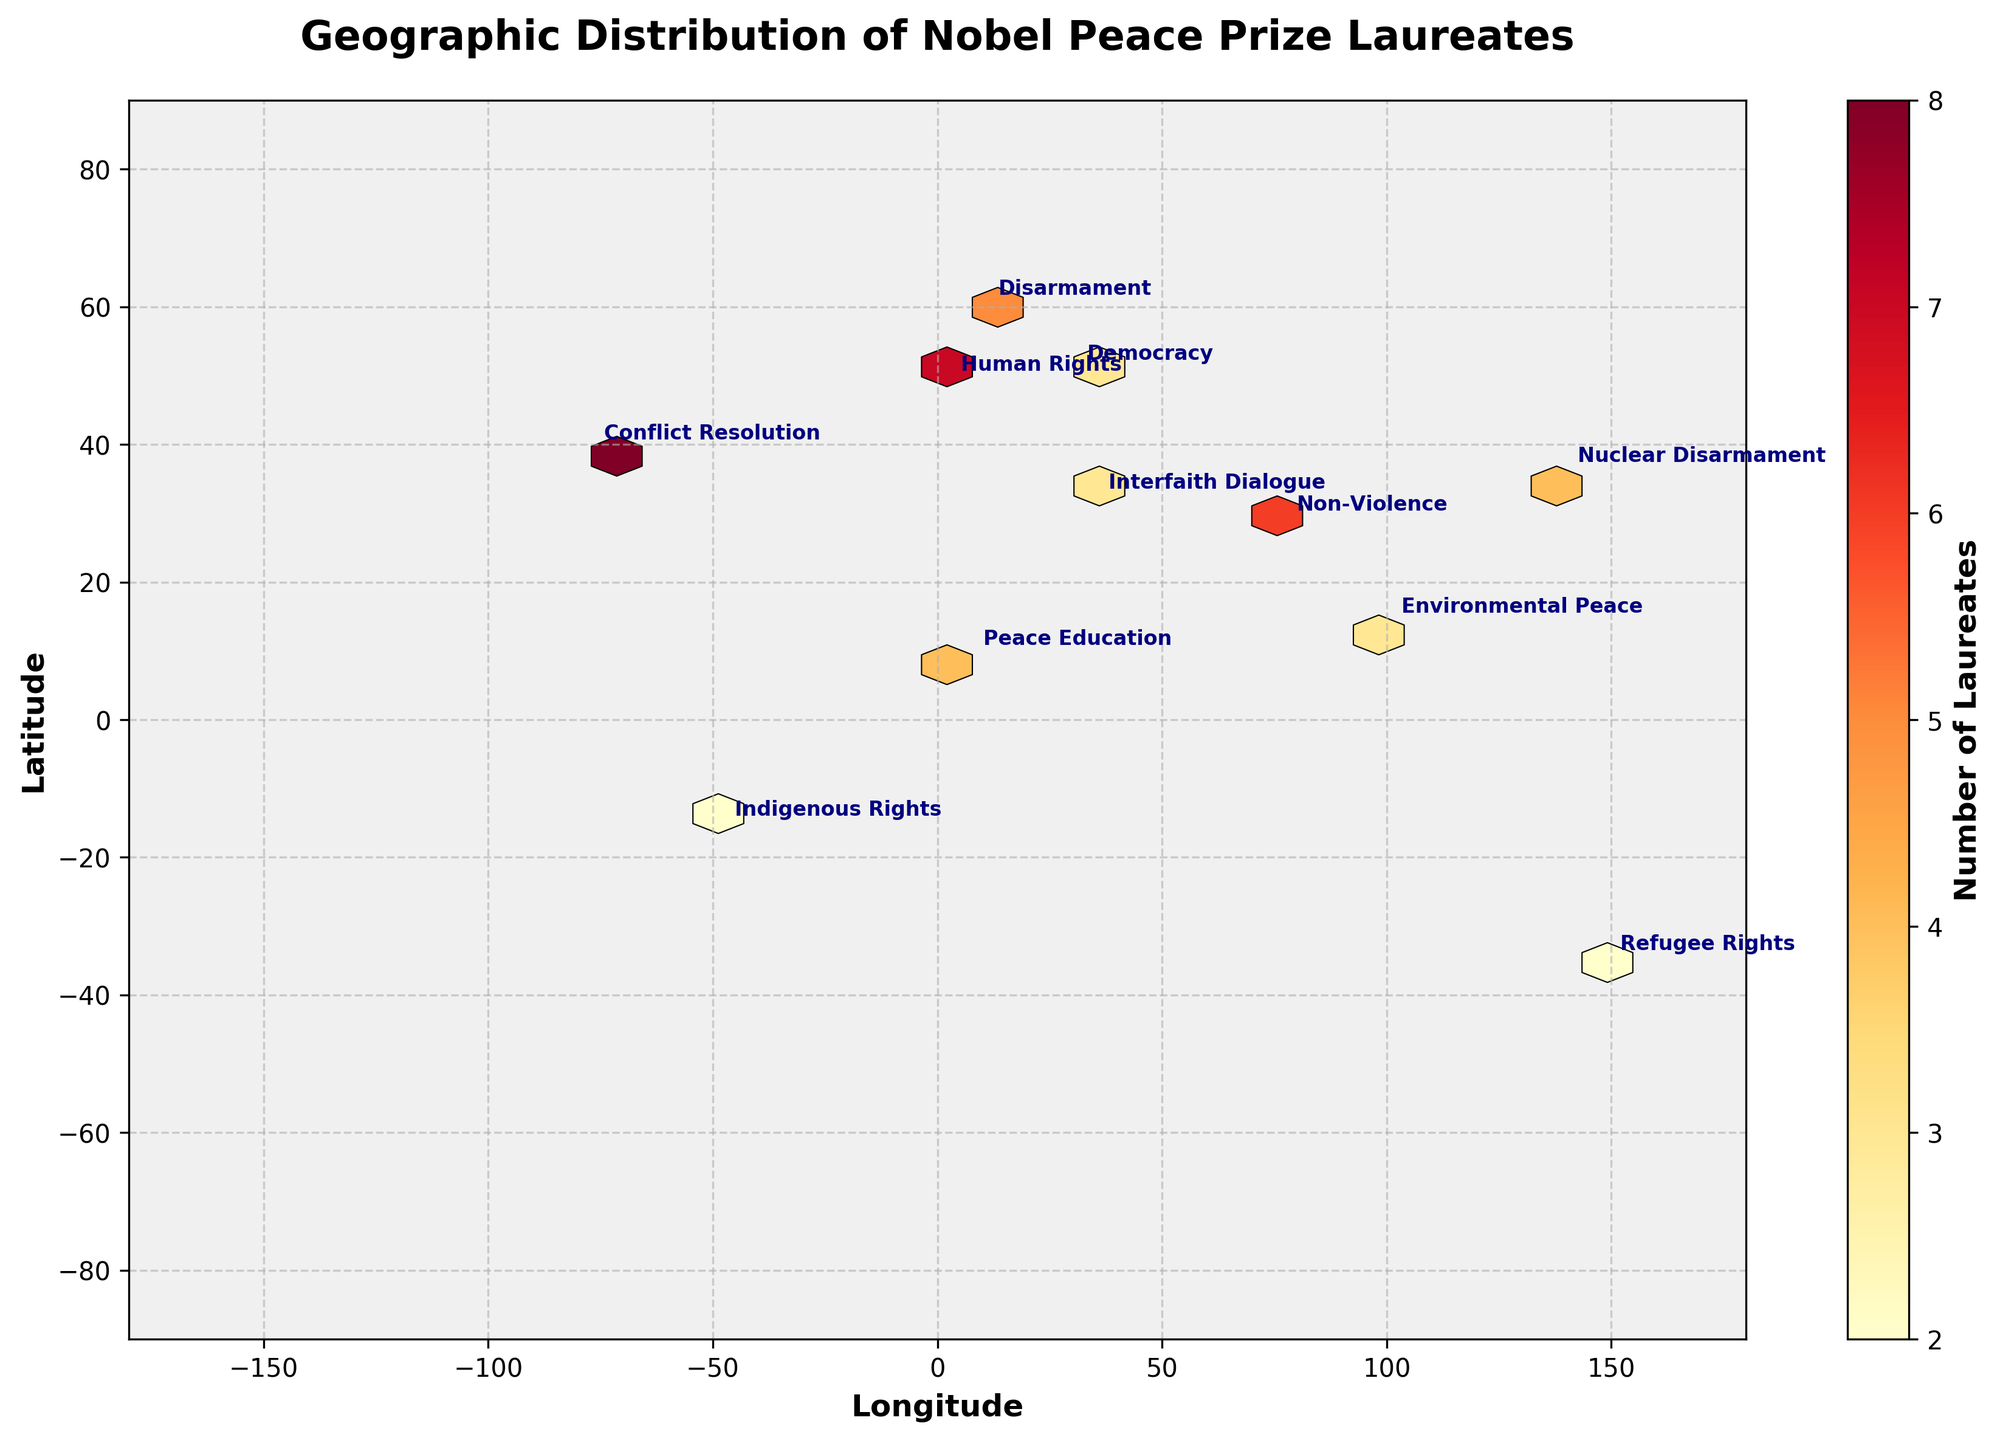What is the title of the plot? The title of the plot is prominently shown at the top in bold letters. It reads: "Geographic Distribution of Nobel Peace Prize Laureates".
Answer: Geographic Distribution of Nobel Peace Prize Laureates What does the color bar represent? The color bar is usually labeled to indicate what it represents. In this figure, it shows "Number of Laureates", which means the color intensity in each hexbin cell shows the count of Nobel Peace Prize laureates.
Answer: Number of Laureates What are the latitude and longitude ranges used in the plot? The plot's axes are labeled, showing geographic coordinates. The latitude range is from -90 to 90 degrees and the longitude range is from -180 to 180 degrees.
Answer: Latitude: -90 to 90, Longitude: -180 to 180 Which region has the highest number of Nobel Peace Prize laureates? The hexbin plot uses color intensity to reflect the number of laureates. The brightest hexagon appears over North America, indicating it has the highest count.
Answer: North America How many laureates are highlighted for Western Europe? An annotation near Western Europe's coordinates (48.8566, 2.3522) shows the label "Human Rights". The color of the cell and the color bar indicate a count of 7 laureates.
Answer: 7 Are there any regions with an equal number of laureates? By examining the color intensity and annotations, we see that both Africa and East Asia have a count of 4 laureates each.
Answer: Yes, Africa and East Asia Compare the laureates' focus areas in Northern and Southern Europe. Northern Europe's annotation shows "Disarmament" with 5 laureates, while Southern Europe isn't listed, meaning it has 0 laureates in this plot.
Answer: Northern Europe: Disarmament, 5; Southern Europe: Not listed Which region is associated with Refugee Rights and how many laureates are there? By checking the annotations, "Refugee Rights" is marked at Oceania's coordinates (-35.2809, 149.1300), and the color intensity indicates 2 laureates.
Answer: Oceania, 2 What is the combined number of laureates in regions focusing on Nuclear Disarmament and Environmental Peace? East Asia (Nuclear Disarmament) has 4 laureates and Southeast Asia (Environmental Peace) has 3 laureates. Summing them, 4 + 3, gives 7 laureates.
Answer: 7 